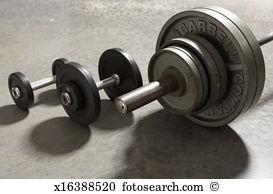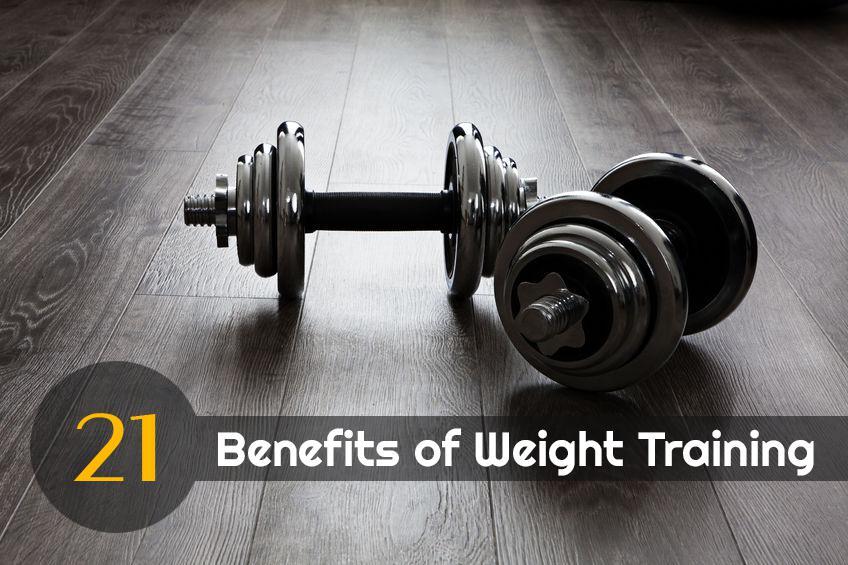The first image is the image on the left, the second image is the image on the right. Evaluate the accuracy of this statement regarding the images: "There is at least one man visible exercising". Is it true? Answer yes or no. No. The first image is the image on the left, the second image is the image on the right. Assess this claim about the two images: "One image shows a human doing pushups.". Correct or not? Answer yes or no. No. 